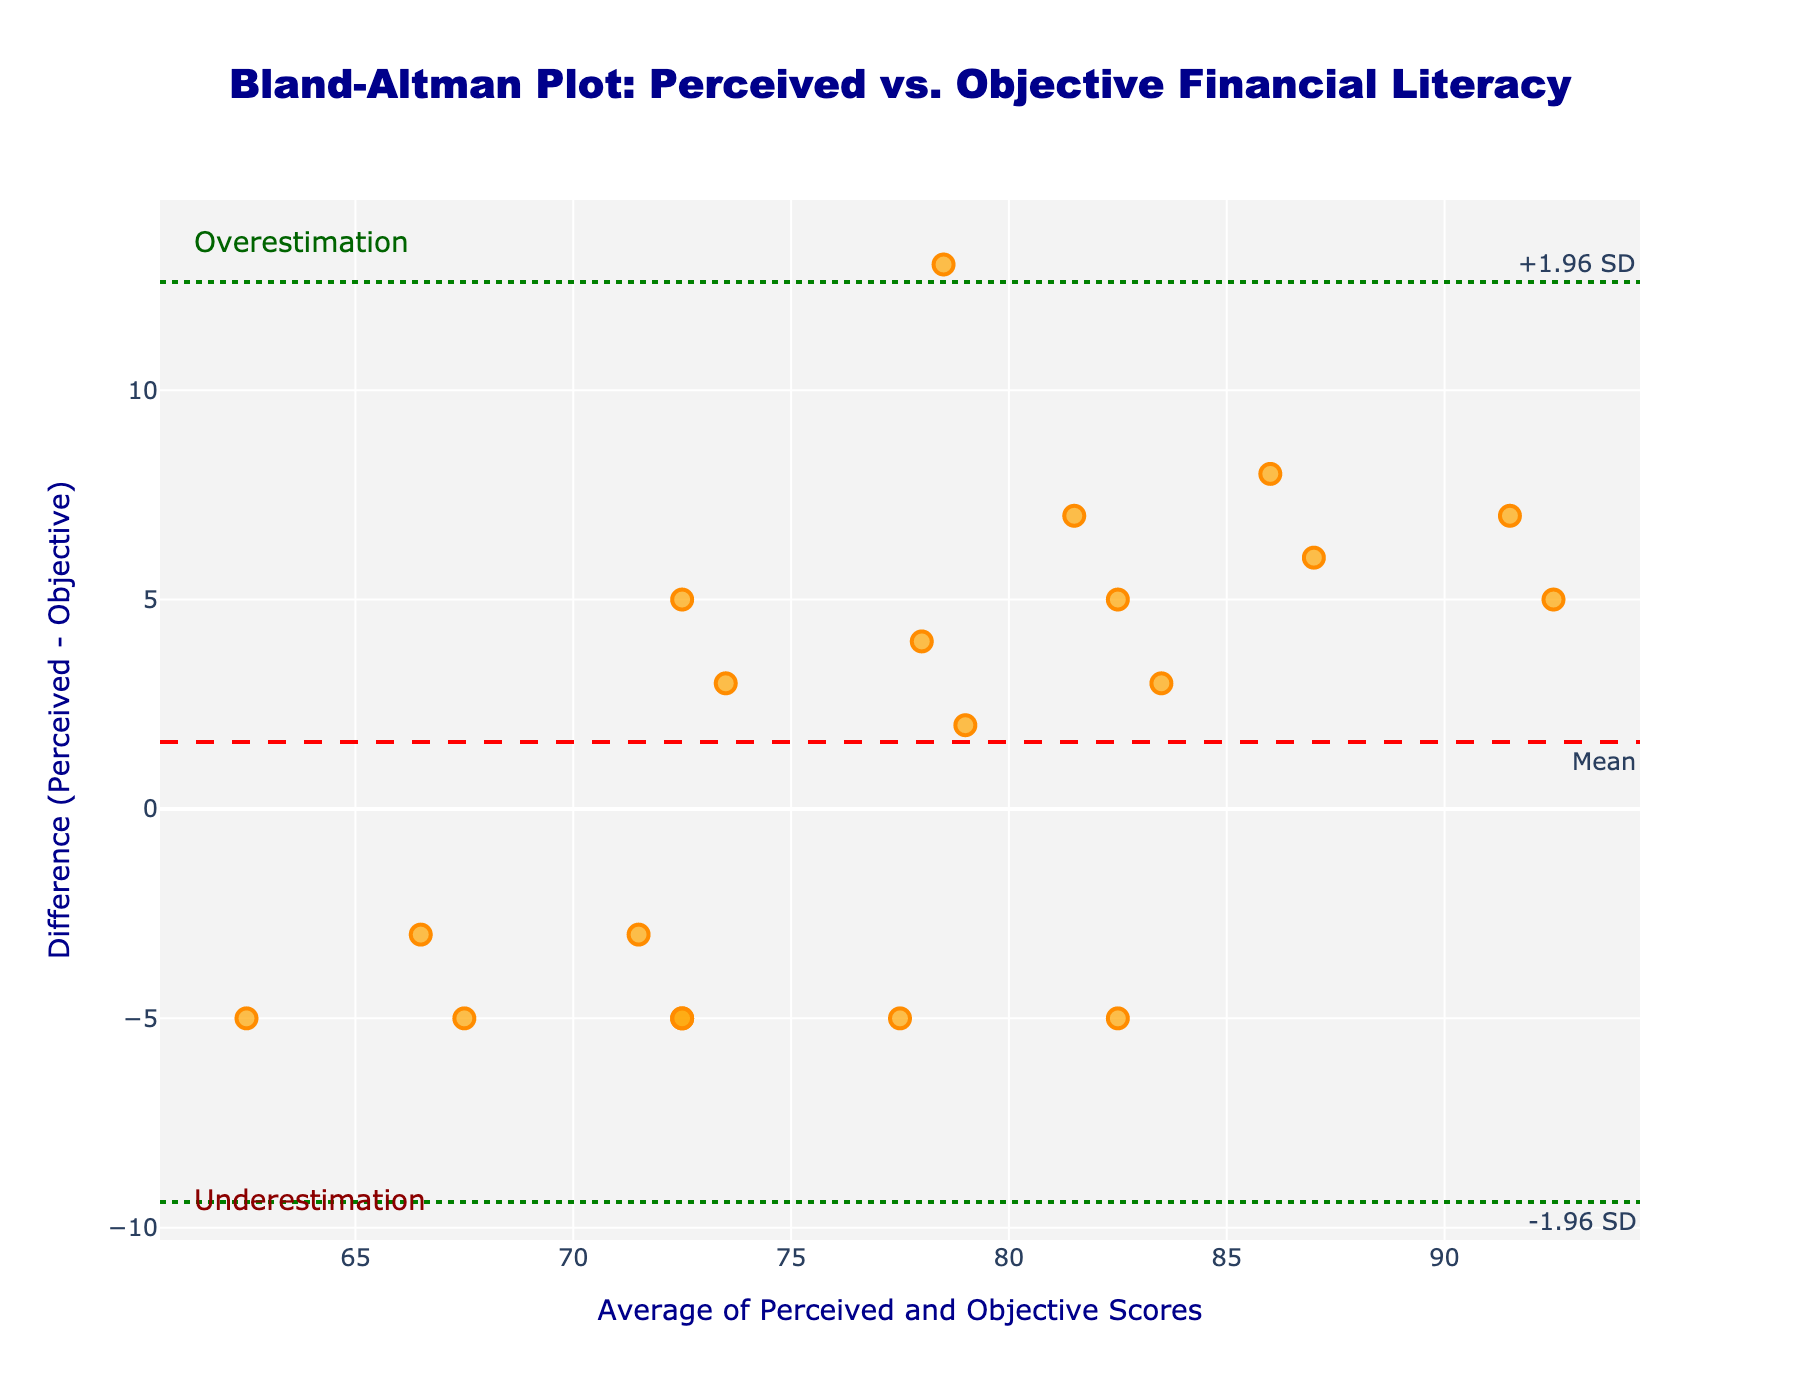What is the title of the figure? The title of the figure is located at the top center. It reads "Bland-Altman Plot: Perceived vs. Objective Financial Literacy".
Answer: Bland-Altman Plot: Perceived vs. Objective Financial Literacy What do the green dotted lines represent? The green dotted lines represent the limits of agreement, which are ±1.96 times the standard deviation above and below the mean difference. They denote the range encompassing most data points if the differences are normally distributed.
Answer: Limits of agreement How many data points show an overestimation of perceived financial literacy compared to the objective score? Overestimation is when the perceived score is higher than the objective score, which places points above the red mean line. Count the points above the red dashed line.
Answer: 8 What does a point above the mean difference line indicate? A point above the mean difference line indicates that the participant's perceived financial literacy is greater than their actual objective score by the Mean Difference or more.
Answer: Perceived > Objective How is the average score between perceived and objective financial literacy calculated for each participant? The average score for each participant is calculated by adding their perceived literacy score to their objective score and dividing by 2. For example, for John Smith, it is (85 + 72) / 2 = 78.5.
Answer: (Perceived + Objective) / 2 Which point has the highest positive difference between perceived literacy and objective score, and what is that difference? The point with the highest positive difference is for John Smith. Check the 'Difference' column and select the maximum value, which is 13.
Answer: 13 (John Smith) Which participant has the smallest average score and what is that score? The smallest average score can be checked in the 'Average' column. Lisa Anderson has the lowest average score of 62.5.
Answer: 62.5 (Lisa Anderson) What is the mean difference between perceived and objective scores? The mean difference is explicitly indicated by the red dashed line in the plot, and it is annotated near the line as "Mean".
Answer: 2.8 Which participant has the largest underestimation and what is the value of that difference? The largest underestimation is Olivia Garcia. Check the 'Difference' column for the most negative value, which is -5.
Answer: -5 (Olivia Garcia) Are there more participants who overestimate or underestimate their financial literacy? Count the number of points above and below the mean line respectively. Since there are 8 points above and 12 below the mean line.
Answer: Underestimate (12 points) vs Overestimate (8 points) 